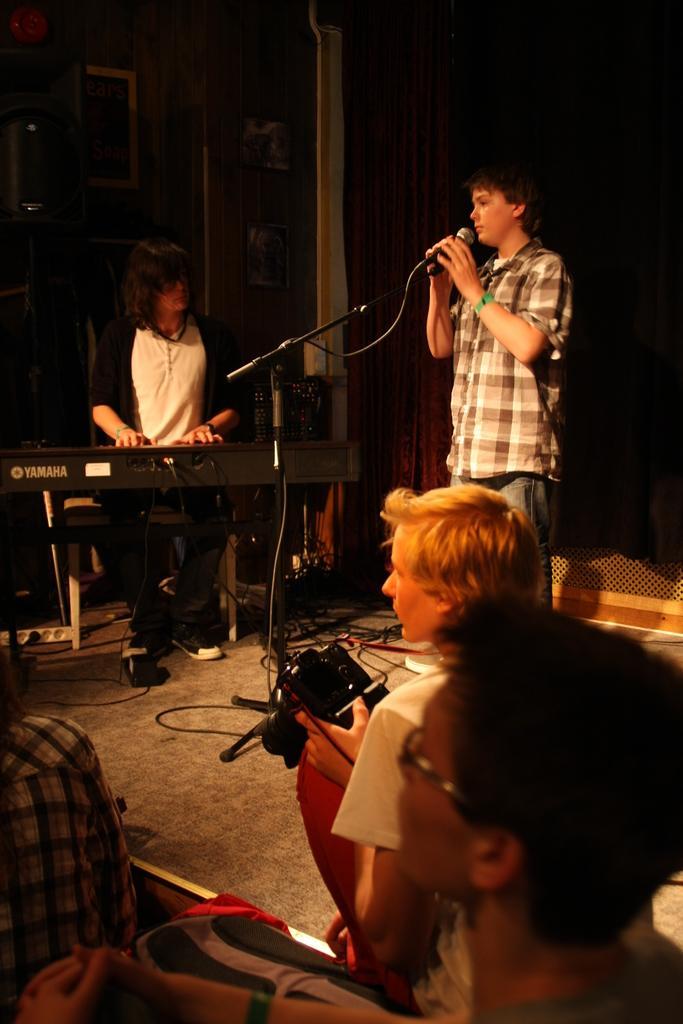In one or two sentences, can you explain what this image depicts? Bottom of the image few people are sitting and he is holding a camera. Top right side of the image a man is standing and holding a microphone. Top left side of the image a woman is sitting and a chair and playing piano. Behind her there are is a wall on the wall there are some frames. 